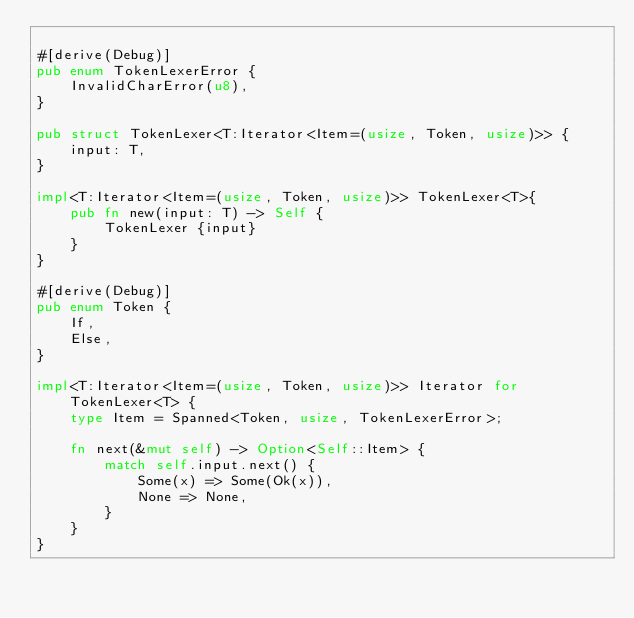<code> <loc_0><loc_0><loc_500><loc_500><_Rust_>
#[derive(Debug)]
pub enum TokenLexerError {
	InvalidCharError(u8),
}

pub struct TokenLexer<T:Iterator<Item=(usize, Token, usize)>> {
	input: T,
}

impl<T:Iterator<Item=(usize, Token, usize)>> TokenLexer<T>{
	pub fn new(input: T) -> Self {
		TokenLexer {input}
	}
}

#[derive(Debug)]
pub enum Token {
	If,
	Else,
}

impl<T:Iterator<Item=(usize, Token, usize)>> Iterator for TokenLexer<T> {
	type Item = Spanned<Token, usize, TokenLexerError>;
	
	fn next(&mut self) -> Option<Self::Item> {
		match self.input.next() {
			Some(x) => Some(Ok(x)),
			None => None,
		}
	}
}



</code> 